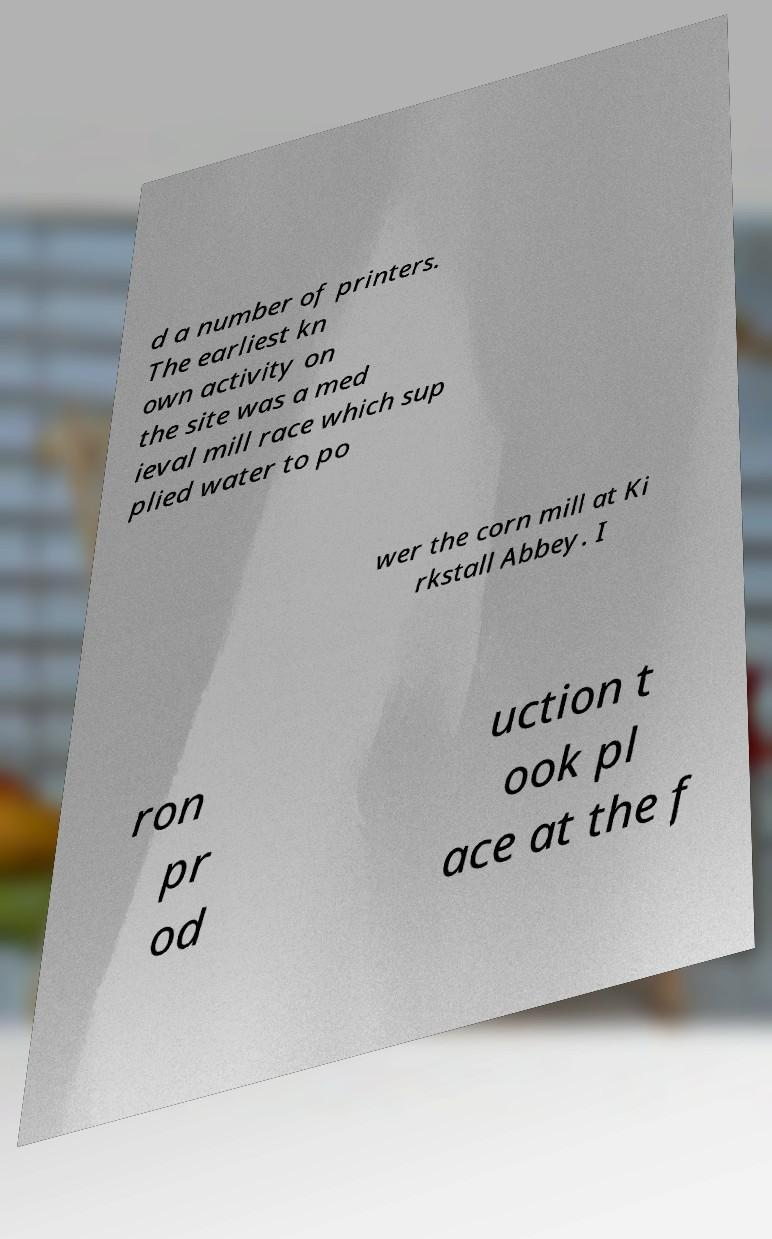There's text embedded in this image that I need extracted. Can you transcribe it verbatim? d a number of printers. The earliest kn own activity on the site was a med ieval mill race which sup plied water to po wer the corn mill at Ki rkstall Abbey. I ron pr od uction t ook pl ace at the f 